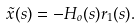<formula> <loc_0><loc_0><loc_500><loc_500>\tilde { x } ( s ) = - H _ { o } ( s ) r _ { 1 } ( s ) .</formula> 